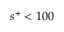Convert formula to latex. <formula><loc_0><loc_0><loc_500><loc_500>s ^ { + } < 1 0 0</formula> 